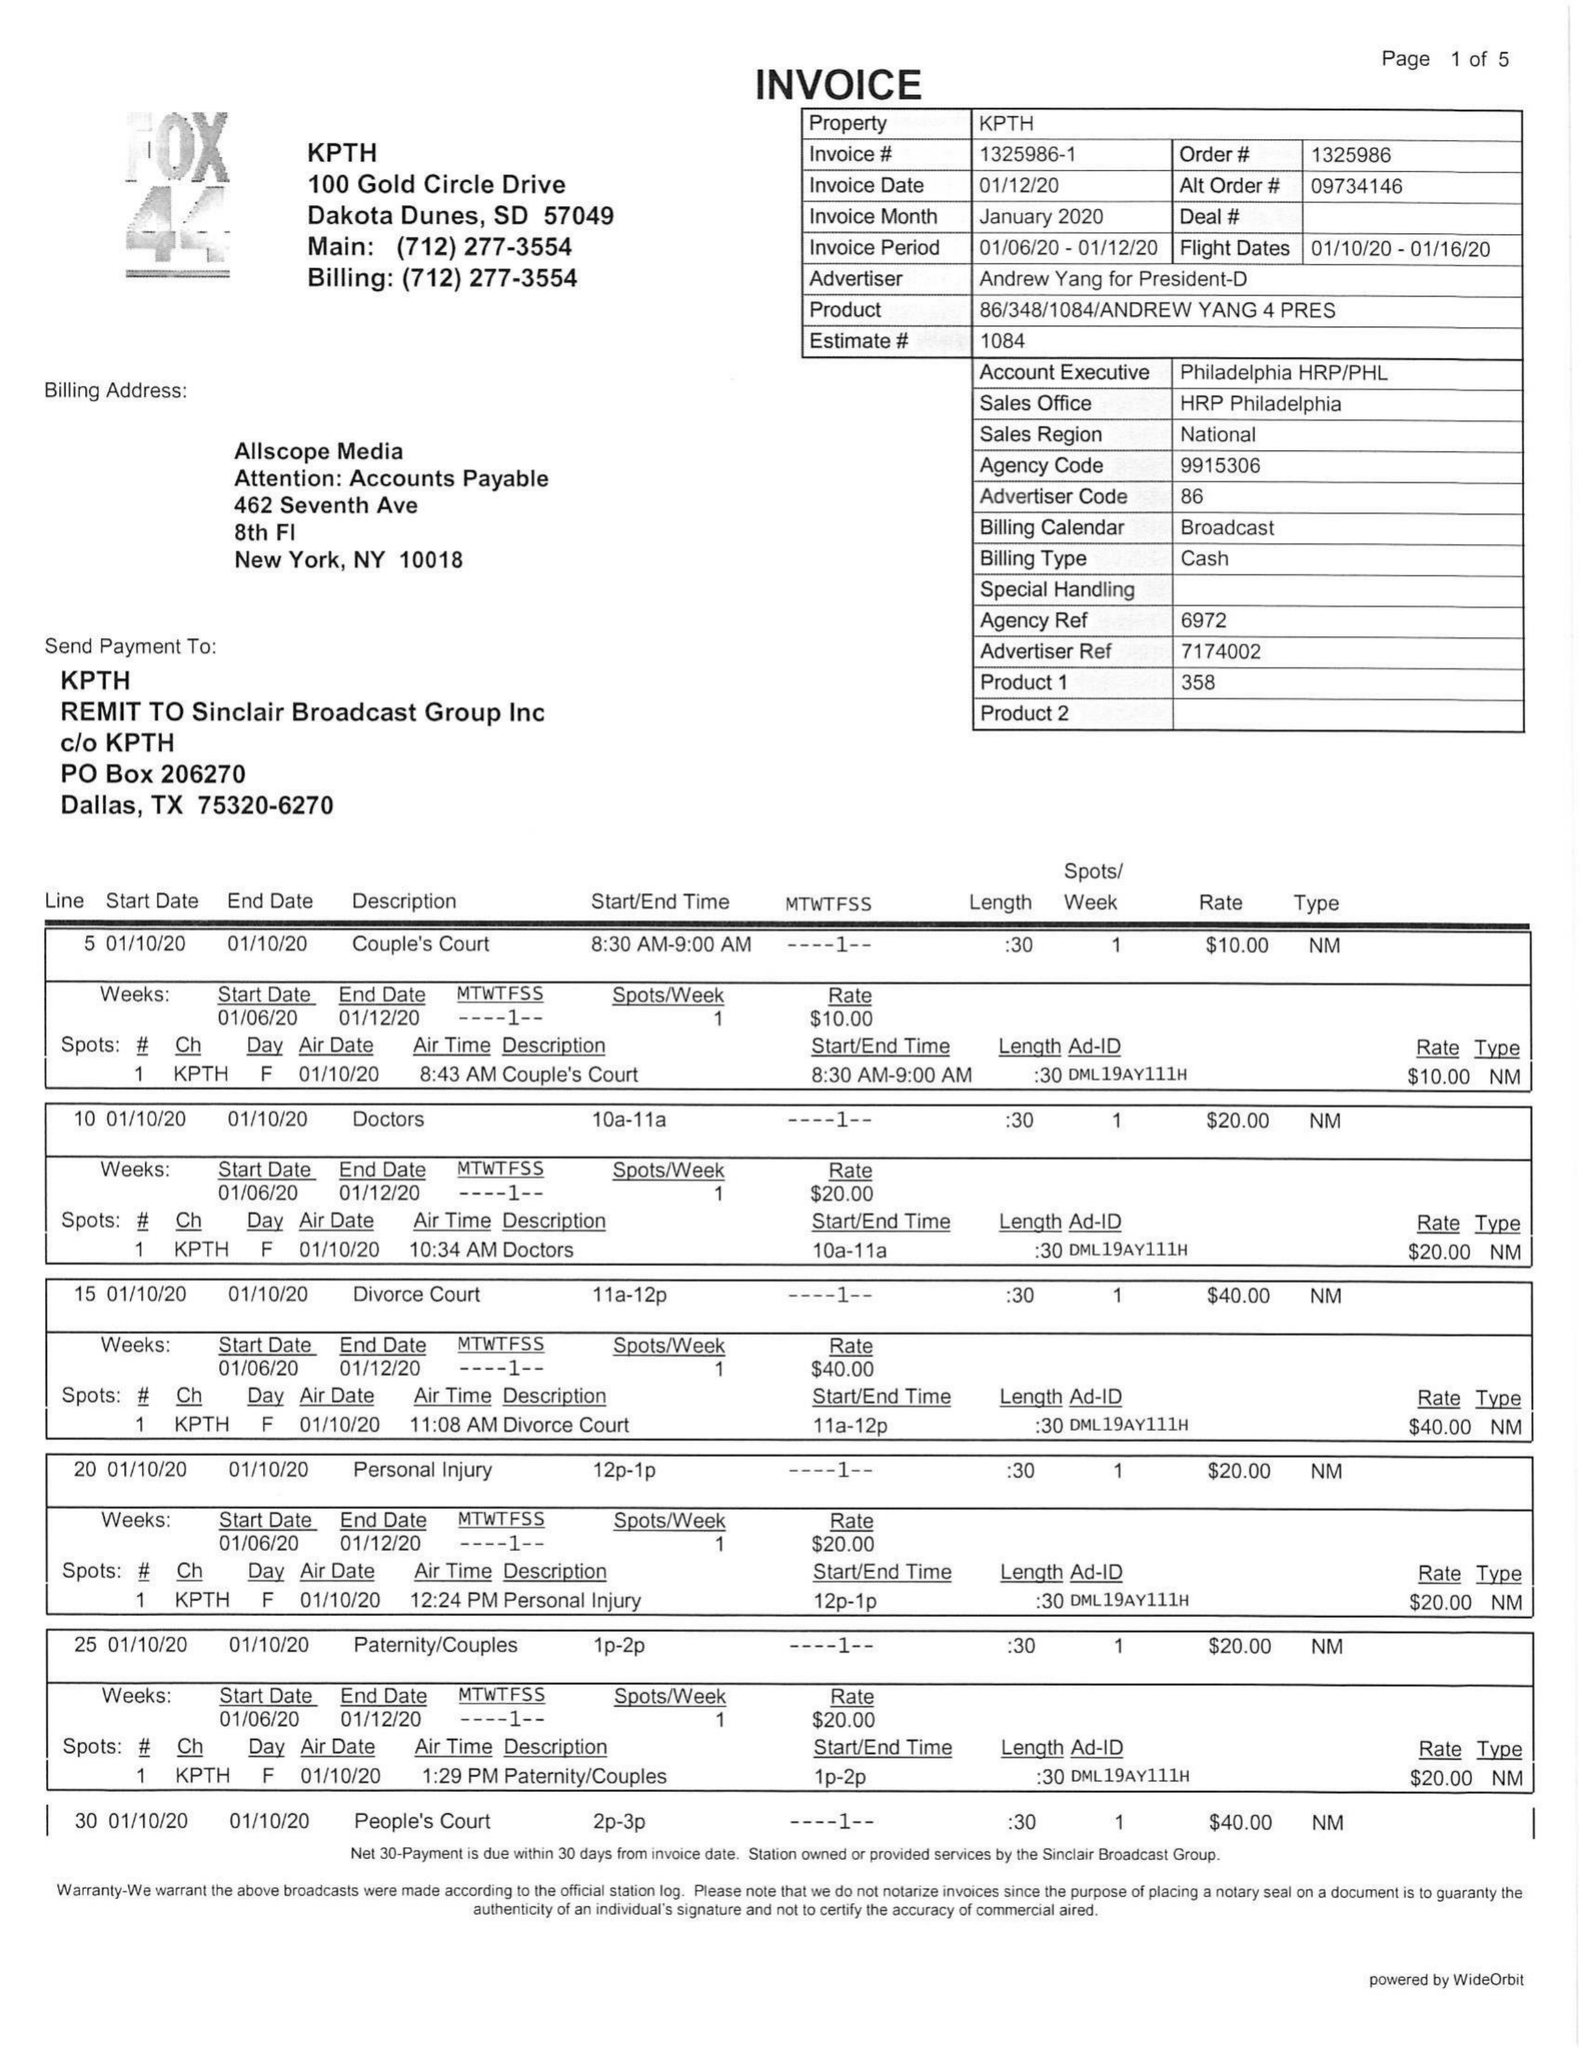What is the value for the contract_num?
Answer the question using a single word or phrase. 1325986 